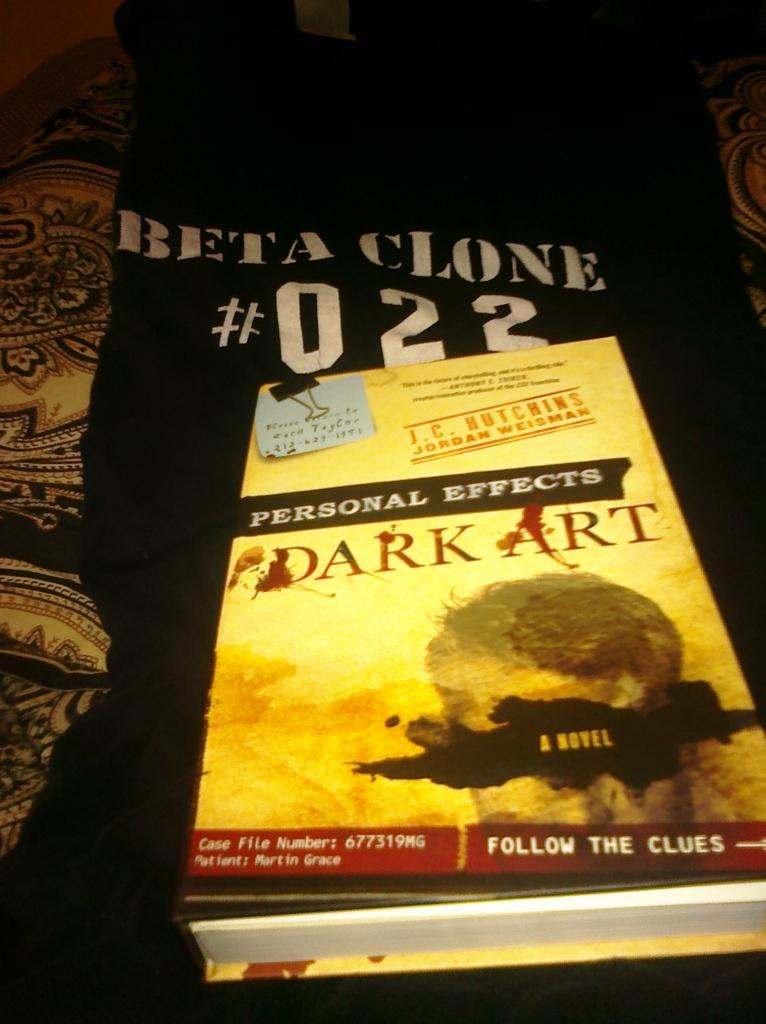<image>
Relay a brief, clear account of the picture shown. Jersey with the number 022 and  a book on top of it called Dark Art 